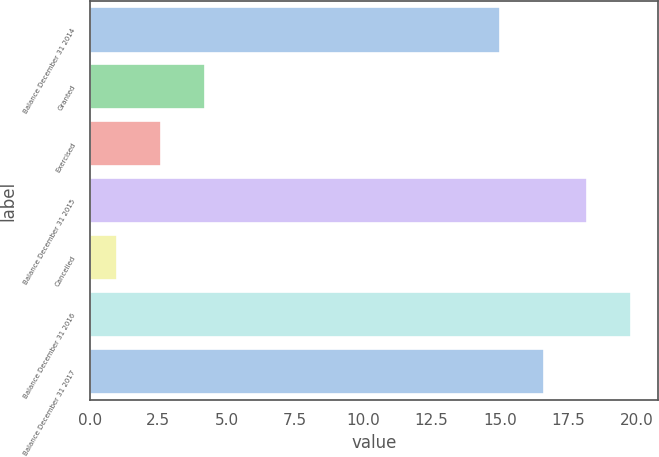<chart> <loc_0><loc_0><loc_500><loc_500><bar_chart><fcel>Balance December 31 2014<fcel>Granted<fcel>Exercised<fcel>Balance December 31 2015<fcel>Cancelled<fcel>Balance December 31 2016<fcel>Balance December 31 2017<nl><fcel>15<fcel>4.2<fcel>2.6<fcel>18.2<fcel>1<fcel>19.8<fcel>16.6<nl></chart> 